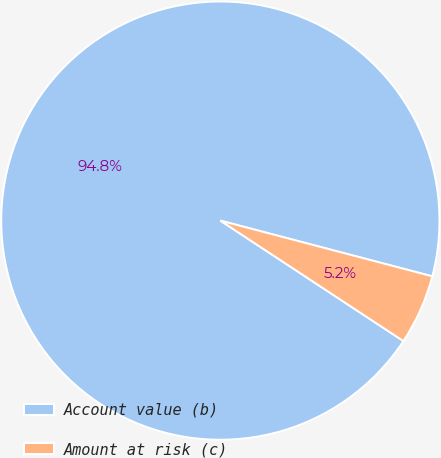Convert chart. <chart><loc_0><loc_0><loc_500><loc_500><pie_chart><fcel>Account value (b)<fcel>Amount at risk (c)<nl><fcel>94.83%<fcel>5.17%<nl></chart> 